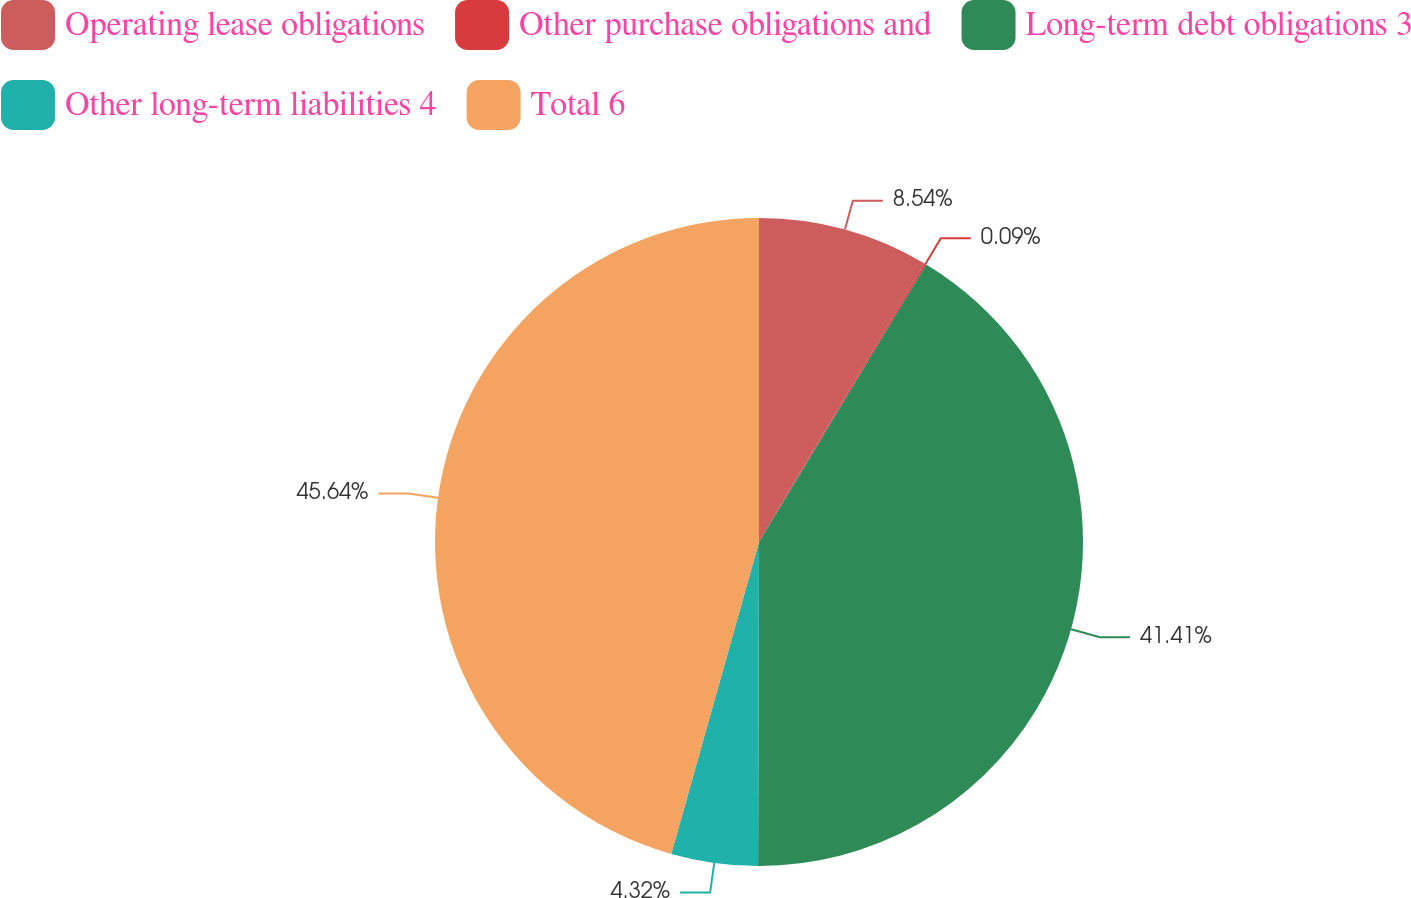Convert chart to OTSL. <chart><loc_0><loc_0><loc_500><loc_500><pie_chart><fcel>Operating lease obligations<fcel>Other purchase obligations and<fcel>Long-term debt obligations 3<fcel>Other long-term liabilities 4<fcel>Total 6<nl><fcel>8.54%<fcel>0.09%<fcel>41.41%<fcel>4.32%<fcel>45.63%<nl></chart> 